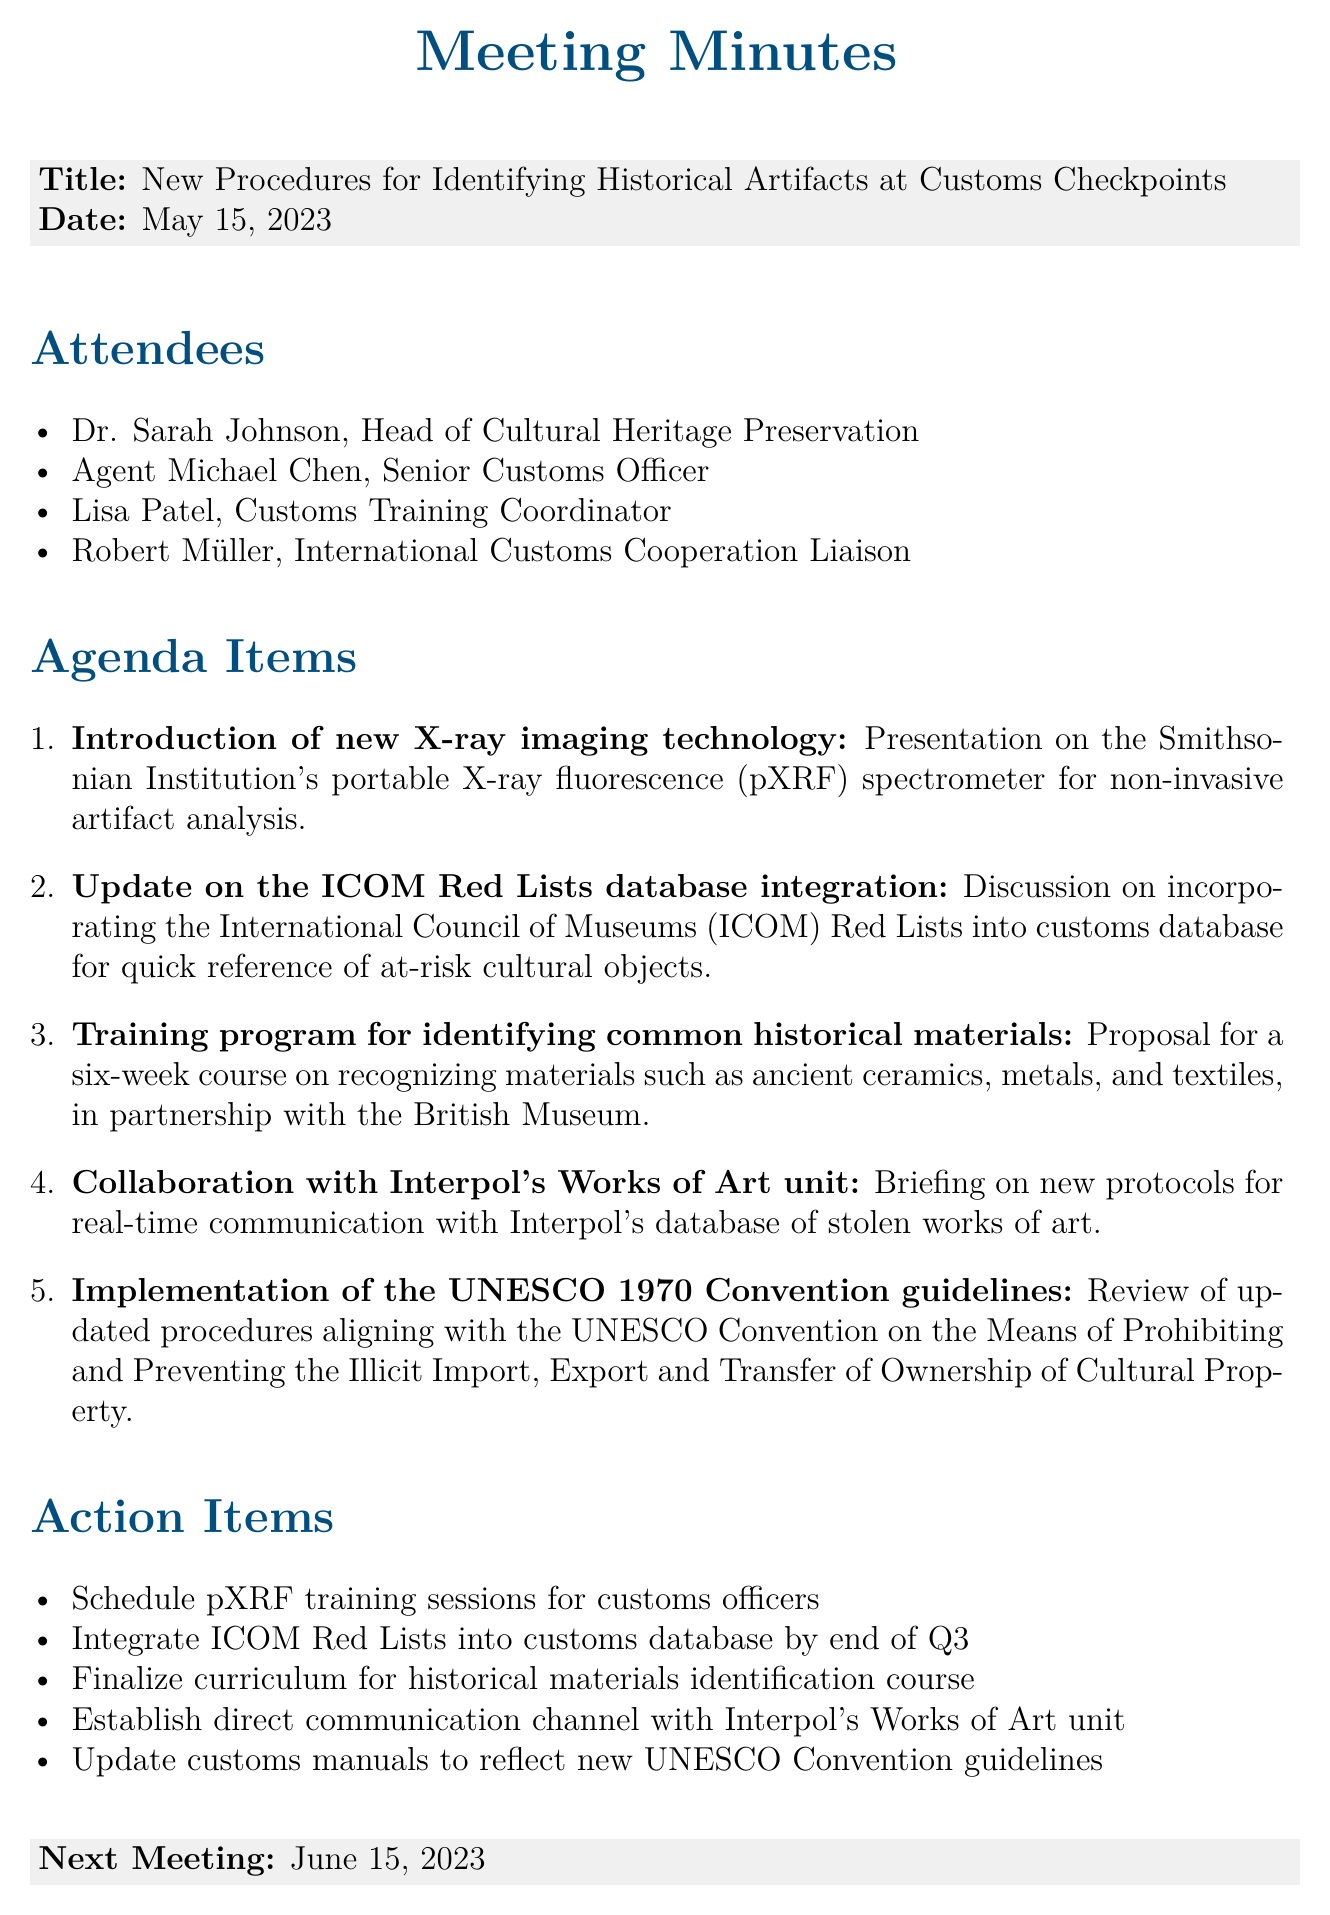What is the meeting title? The meeting title is stated at the beginning of the document under the title section.
Answer: New Procedures for Identifying Historical Artifacts at Customs Checkpoints Who presented the new X-ray imaging technology? The information regarding the presentation is found under the agenda items, specifically mentioning the presenter by title.
Answer: Smithsonian Institution What is the date of the next meeting? The next meeting date is clearly stated in the document towards the end, under the next meeting section.
Answer: June 15, 2023 How many attendees are listed in the document? The number of attendees is found in the attendees section listed as items.
Answer: Four What is the proposed duration of the training program? The duration is specified in the agenda item discussing the training program.
Answer: Six weeks What is one action item related to the pXRF training? The action items outlined in the document contain specific tasks, one of which pertains to pXRF training.
Answer: Schedule pXRF training sessions for customs officers Which organization's guidelines are mentioned for implementation? The document includes a section detailing which guidelines are to be updated, indicating their source.
Answer: UNESCO 1970 Convention What is the purpose of integrating the ICOM Red Lists? The agenda item states a specific purpose for this integration, as noted in the detailed explanation.
Answer: Quick reference of at-risk cultural objects 